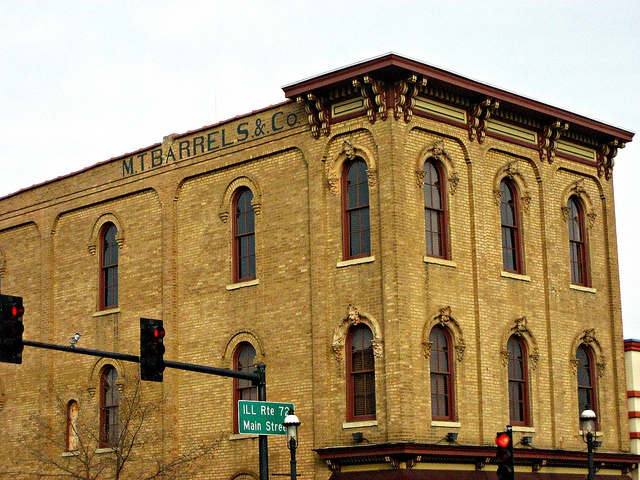Describe the objects in this image and their specific colors. I can see traffic light in white, black, maroon, and tan tones, traffic light in white, black, maroon, olive, and red tones, and traffic light in white, black, red, and maroon tones in this image. 